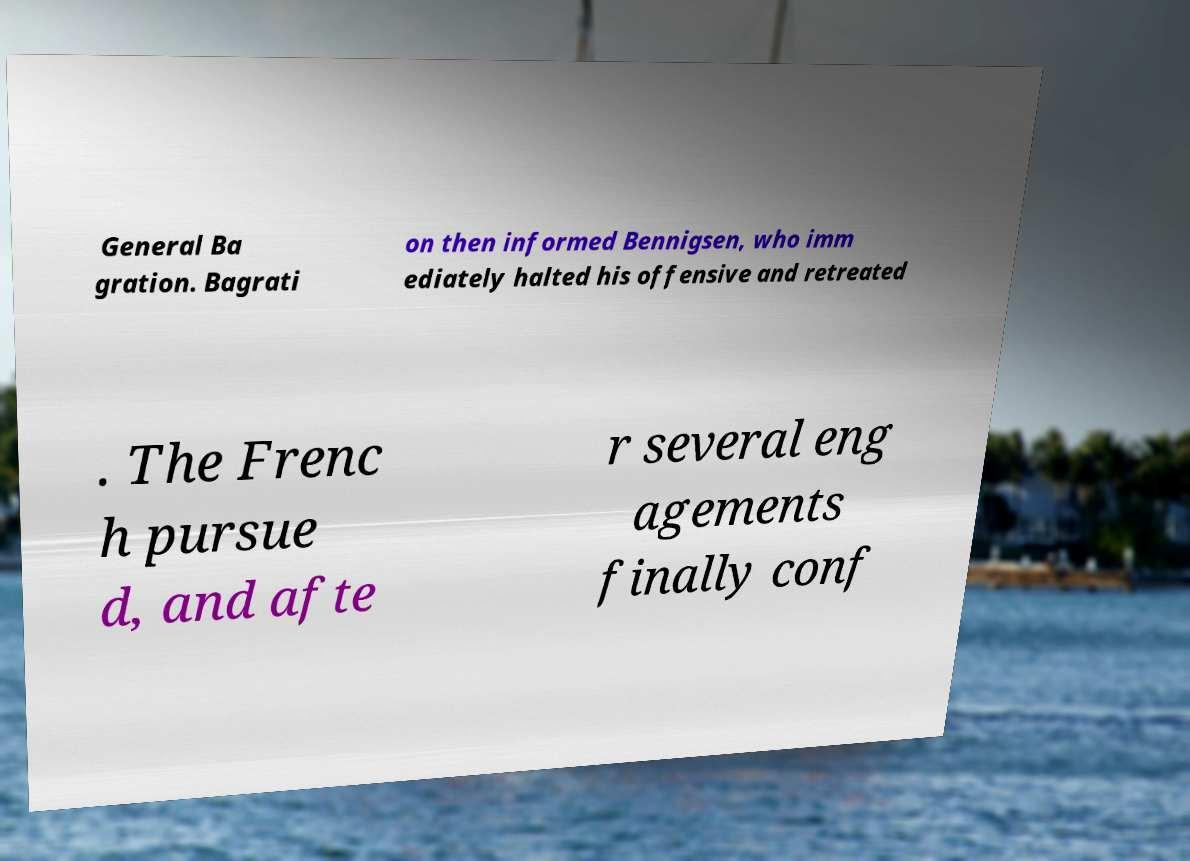What messages or text are displayed in this image? I need them in a readable, typed format. General Ba gration. Bagrati on then informed Bennigsen, who imm ediately halted his offensive and retreated . The Frenc h pursue d, and afte r several eng agements finally conf 